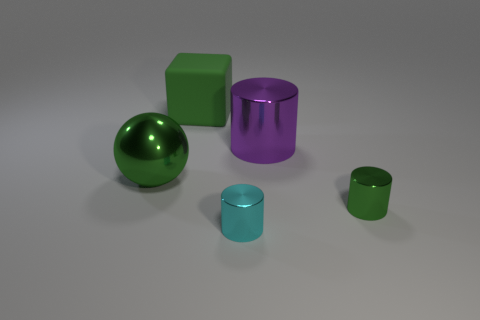Is the number of cubes behind the green shiny ball greater than the number of metal cylinders right of the green cylinder?
Offer a terse response. Yes. What color is the tiny cylinder that is in front of the green thing that is in front of the big green metallic thing?
Your response must be concise. Cyan. What number of cylinders are either large blue rubber objects or green things?
Give a very brief answer. 1. What number of objects are right of the big shiny sphere and left of the big green block?
Your answer should be compact. 0. There is a tiny thing that is on the right side of the large purple object; what is its color?
Make the answer very short. Green. What is the size of the purple cylinder that is made of the same material as the big green sphere?
Ensure brevity in your answer.  Large. There is a small object that is behind the small cyan thing; how many cubes are right of it?
Your answer should be compact. 0. There is a small green metal cylinder; what number of green metallic objects are in front of it?
Provide a succinct answer. 0. There is a big metal thing that is to the right of the object behind the purple metal object that is on the right side of the ball; what is its color?
Your response must be concise. Purple. There is a large thing behind the purple metal thing; is its color the same as the object that is to the left of the rubber object?
Provide a short and direct response. Yes. 